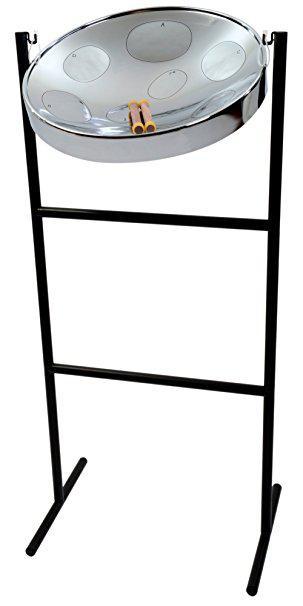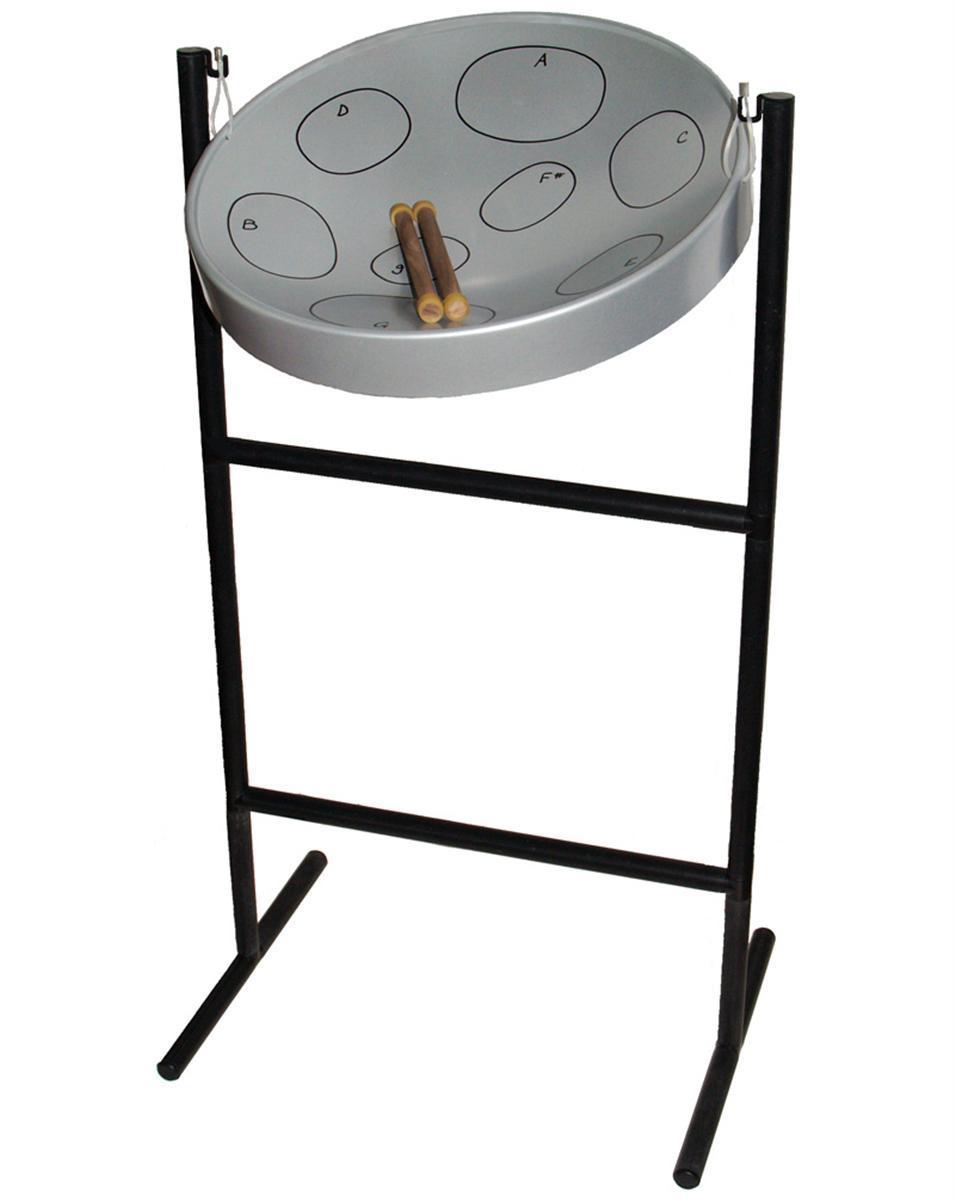The first image is the image on the left, the second image is the image on the right. Given the left and right images, does the statement "The right image features one drum with a concave top on a pivoting black stand, and the left image includes at least one cylindrical flat-topped drum displayed sitting on a flat side." hold true? Answer yes or no. No. The first image is the image on the left, the second image is the image on the right. Analyze the images presented: Is the assertion "There are drums stacked on top of one another." valid? Answer yes or no. No. 